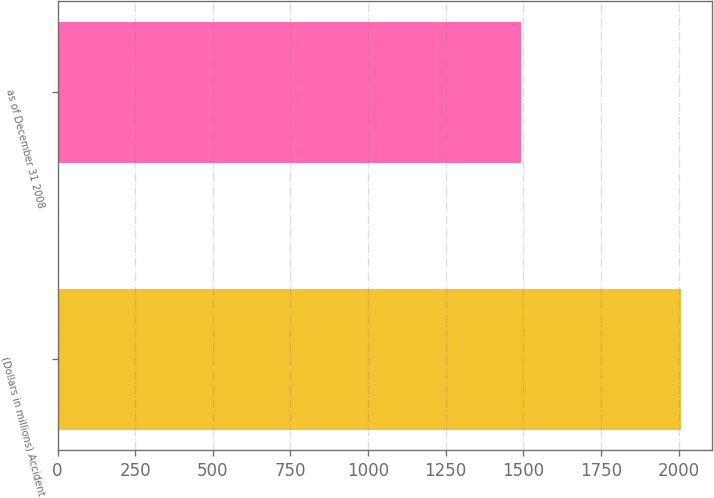<chart> <loc_0><loc_0><loc_500><loc_500><bar_chart><fcel>(Dollars in millions) Accident<fcel>as of December 31 2008<nl><fcel>2007<fcel>1493<nl></chart> 